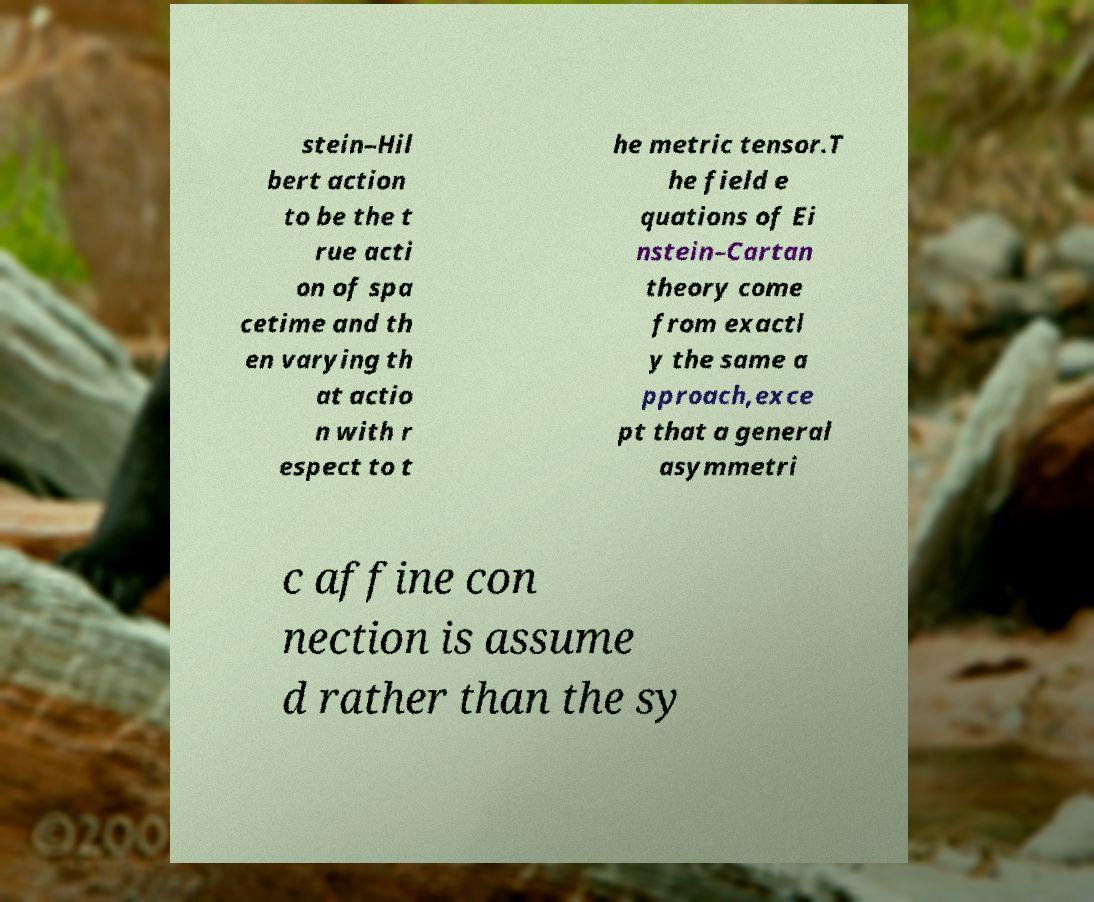For documentation purposes, I need the text within this image transcribed. Could you provide that? stein–Hil bert action to be the t rue acti on of spa cetime and th en varying th at actio n with r espect to t he metric tensor.T he field e quations of Ei nstein–Cartan theory come from exactl y the same a pproach,exce pt that a general asymmetri c affine con nection is assume d rather than the sy 